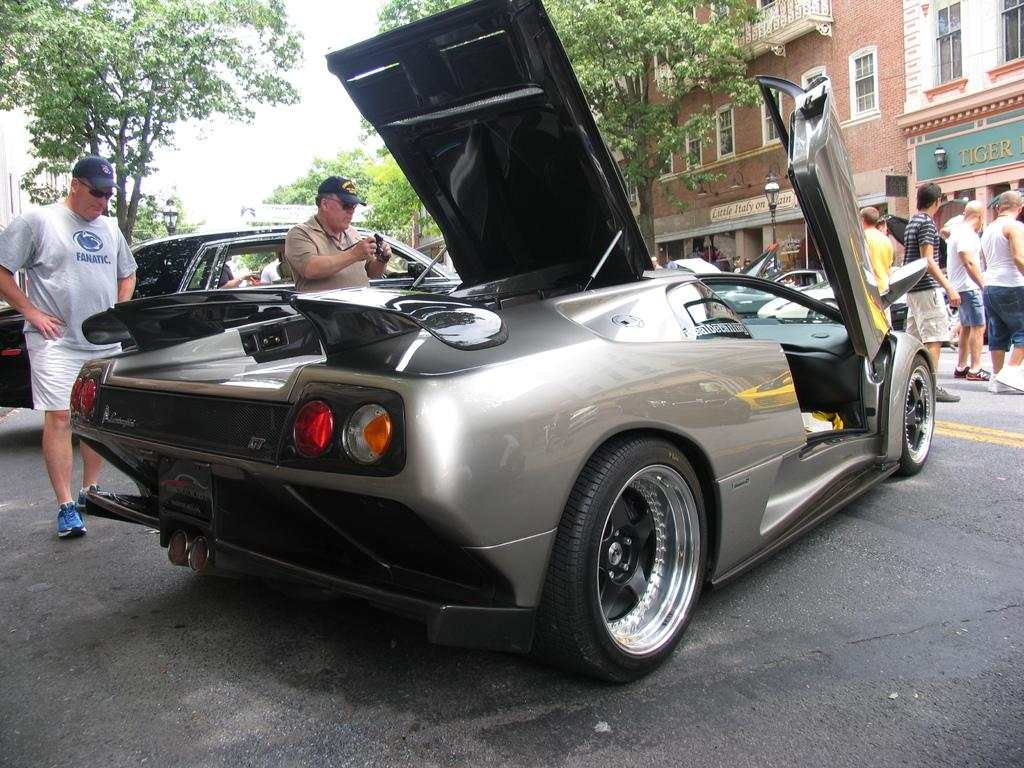What type of vehicle is in the image? There is a sports car in the image. Who is present in the image besides the sports car? A man is standing on the left side of the image. What is the man wearing on his head? The man is wearing a black cap. What type of natural elements can be seen in the image? There are trees in the image. What type of structures can be seen in the image? There are buildings on the right side of the image. How many feet are visible in the image? There is no mention of feet in the image, so it is not possible to determine how many are visible. 